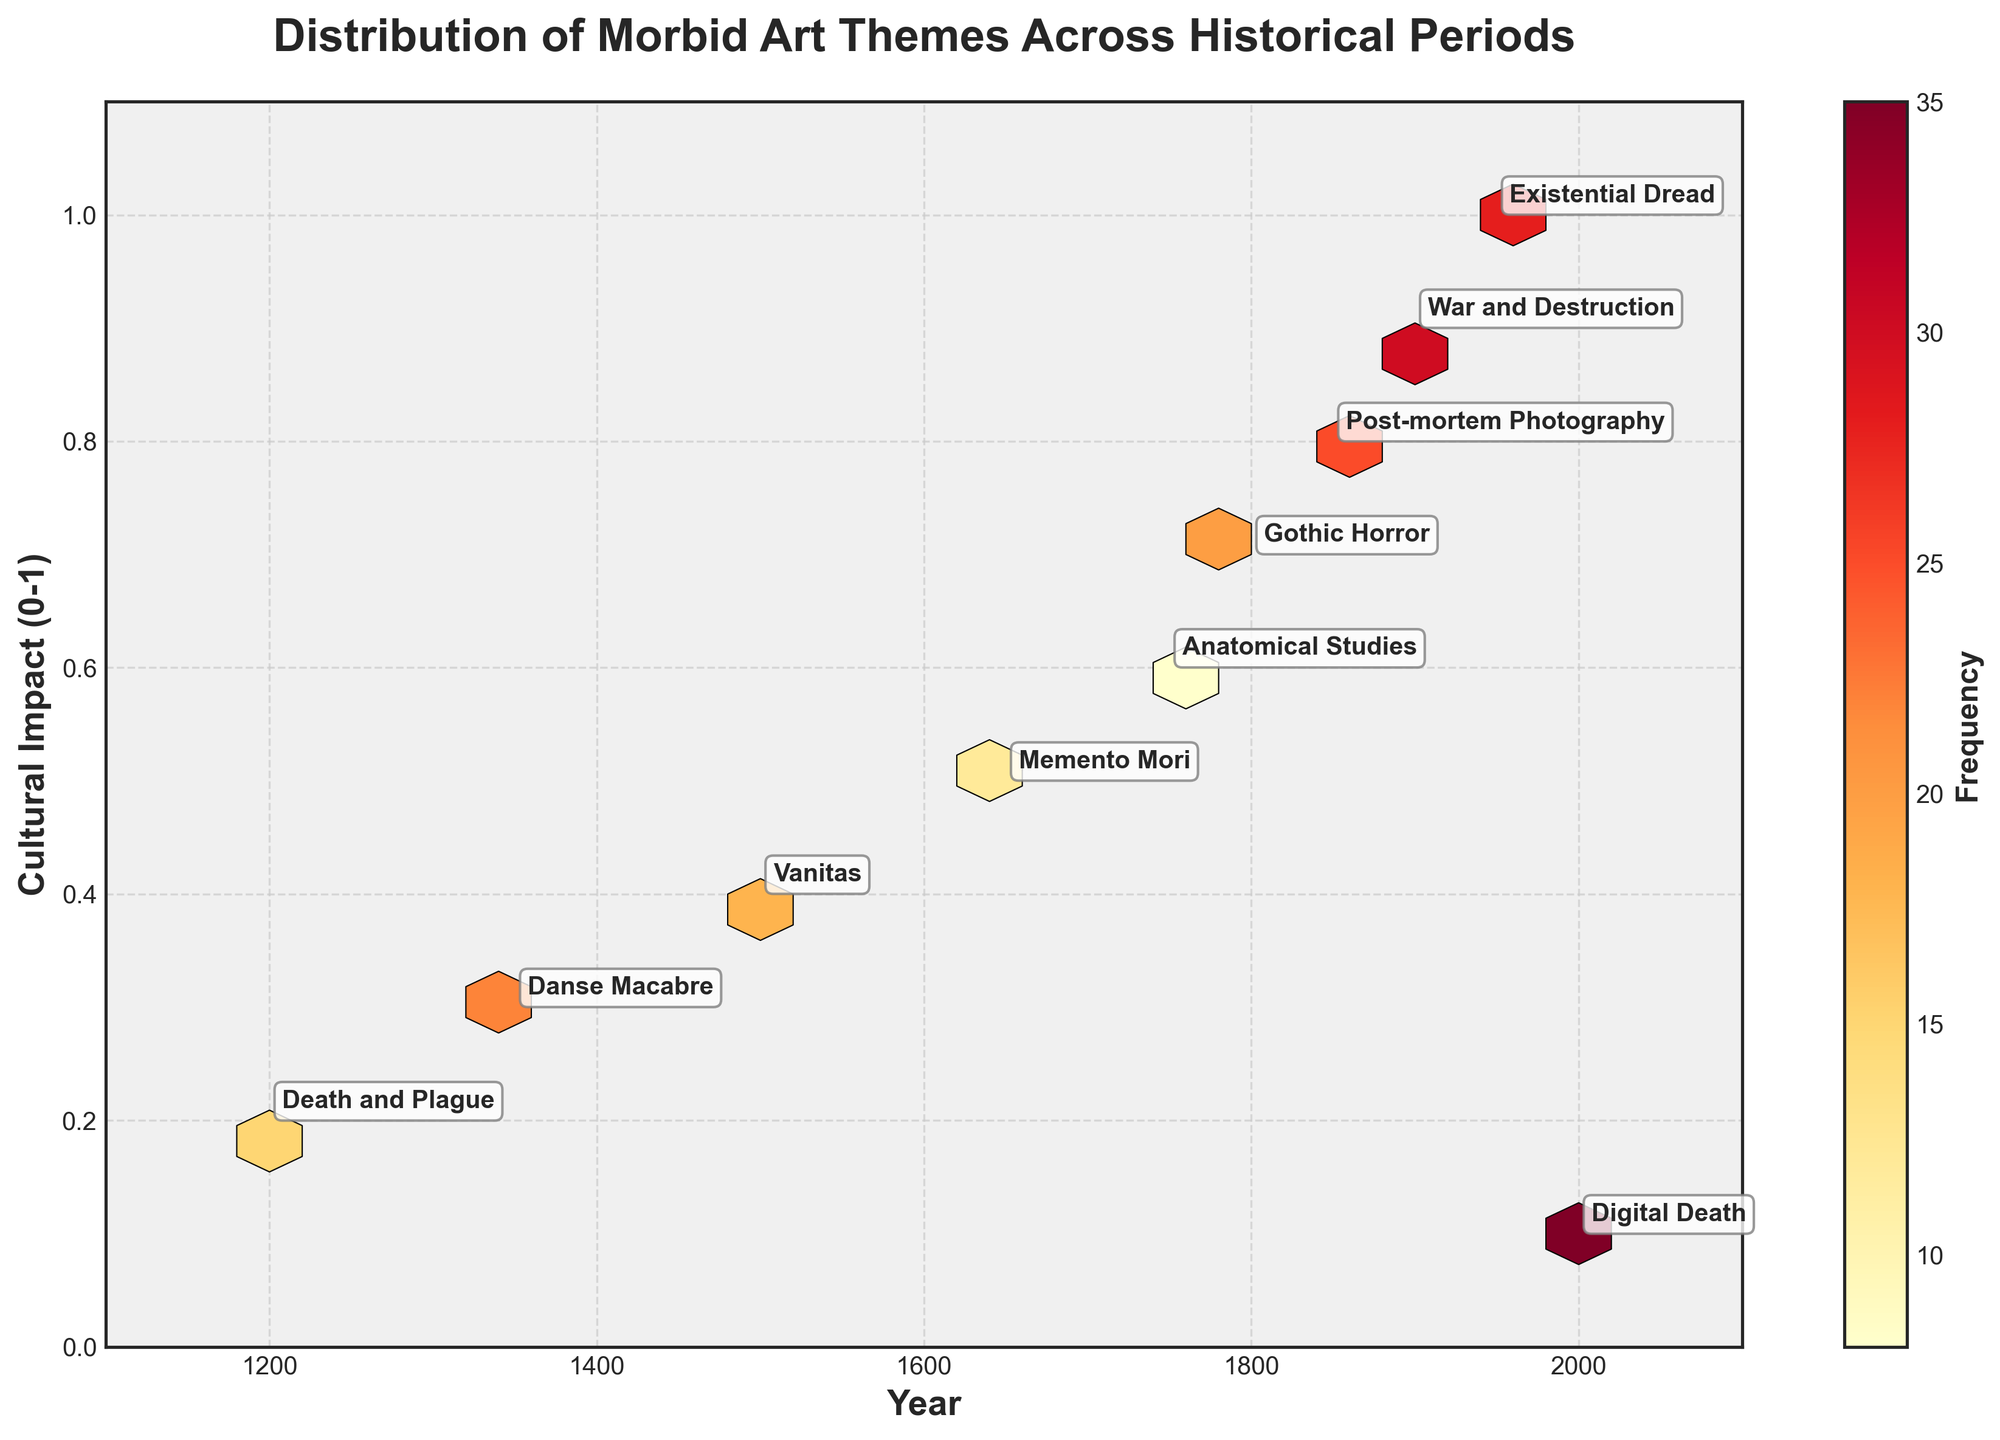What is the title of the figure? The title of a figure is usually found at the top and provides a summary of what the figure is about. In this case, it reads "Distribution of Morbid Art Themes Across Historical Periods".
Answer: Distribution of Morbid Art Themes Across Historical Periods What information is represented on the x-axis? The x-axis typically indicates the independent variable, which in this plot is labeled 'Year'. This axis runs from 1100 to 2100 in the figure.
Answer: Year What information is represented on the y-axis? The y-axis usually shows the dependent variable, which in this plot is labeled 'Cultural Impact (0-1)'. This axis ranges from 0 to 1.1 in the figure.
Answer: Cultural Impact (0-1) What does the color of the hexagons represent? The hexagons in a hexbin plot can visually encode data in various ways; in this figure, their color represents the 'Frequency' of morbid art themes, with a color shade indicating different levels of concentration or density of data points.
Answer: Frequency Which historical period has the highest frequency of morbid art themes? Observing the color and annotation within the hexagons helps in identifying the historical period with the highest value. The most intense color shade, representing the highest frequency, is seen in the hexagon for 'Digital Death' in the Contemporary period, which has a frequency of 35.
Answer: Contemporary What historical period has the theme 'Vanitas', and how frequent is it? The labels on the hexagons indicate the historical period and theme. According to the annotations, 'Vanitas' belongs to the Renaissance period with a frequency of 18.
Answer: Renaissance, 18 Which themes appear in the Late Medieval and Post-modern periods, and how do their cultural impacts compare? Identifying the hexagons labeled 'Danse Macabre' and 'Existential Dread', and comparing their vertical positions on the y-axis, shows that 'Danse Macabre' (Late Medieval) has a cultural impact of 0.3, while 'Existential Dread' (Post-modern) has a cultural impact of 1.0, which is significantly higher.
Answer: Danse Macabre has a cultural impact of 0.3, Existential Dread has a cultural impact of 1.0 How does the frequency of 'Post-mortem Photography' compare to 'Vanitas'? Observing the weights annotated beside each theme reveals that 'Post-mortem Photography' in the Victorian period has a frequency of 25, which is higher than 'Vanitas' in the Renaissance period with a frequency of 18.
Answer: Post-mortem Photography's frequency is higher than Vanitas' What can be inferred about the cultural impact trend of morbid art themes from Medieval to Contemporary periods? By tracing the vertical positions of the annotated data points from left to right (Medieval to Contemporary), we observe a general upward trend, indicating that the cultural impact values of morbid art themes increased over time.
Answer: Cultural impact increased over time Which theme has the lowest cultural impact and in which period does it occur? The theme with the lowest position on the y-axis represents the lowest cultural impact. According to the annotations, 'Digital Death' in the Contemporary period has the lowest cultural impact of 0.1.
Answer: Digital Death, Contemporary 